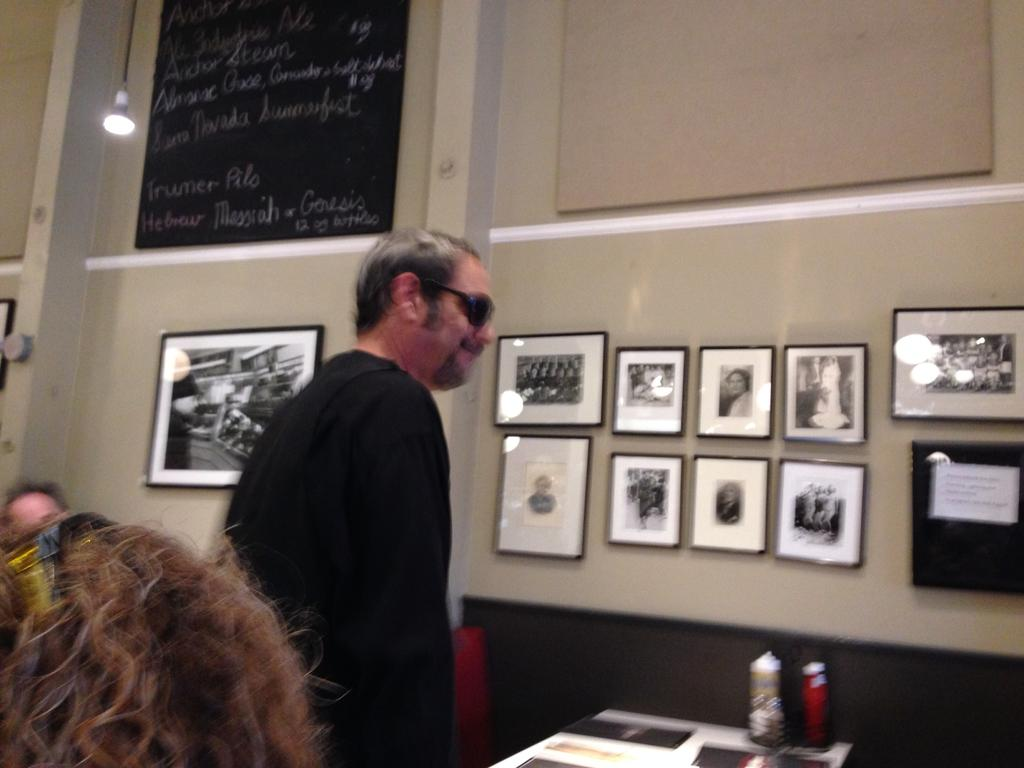What is the main subject of the image? There is a man standing in the middle of the image. Can you describe the man's attire? The man is wearing black spots and a black dress. What can be seen on the wall in the image? There are photographic frames on the wall. Where is the light source located in the image? There is a light on the left side of the image. What type of gold object is the man holding in the image? There is no gold object present in the image, and the man is not holding anything. Can you tell me how many spotlights are illuminating the man in the image? The image does not show any spotlights; there is only a light on the left side of the image. 